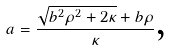Convert formula to latex. <formula><loc_0><loc_0><loc_500><loc_500>a = \frac { \sqrt { b ^ { 2 } \rho ^ { 2 } + 2 \kappa } + b \rho } { \kappa } \text {,}</formula> 